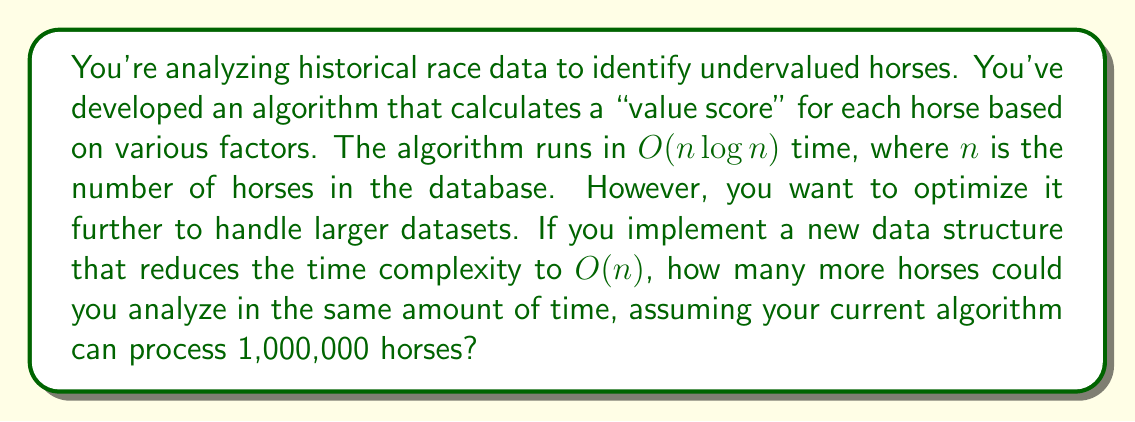Give your solution to this math problem. Let's approach this step-by-step:

1) The current algorithm runs in $O(n \log n)$ time. For $n = 1,000,000$, this is proportional to:

   $1,000,000 \log_2(1,000,000) \approx 19,931,568$

2) The new algorithm runs in $O(n)$ time. Let's call the new number of horses $x$. We want to find $x$ such that:

   $x = 19,931,568$

3) This is because we want the new algorithm to take the same amount of time as the old one, but process more horses.

4) Solving for $x$:

   $x = 19,931,568$

5) This means the new algorithm can process 19,931,568 horses in the same time the old algorithm processes 1,000,000 horses.

6) To find how many more horses this is:

   $19,931,568 - 1,000,000 = 18,931,568$

Therefore, the new algorithm can process 18,931,568 more horses in the same amount of time.
Answer: 18,931,568 more horses 